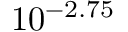<formula> <loc_0><loc_0><loc_500><loc_500>1 0 ^ { - 2 . 7 5 }</formula> 